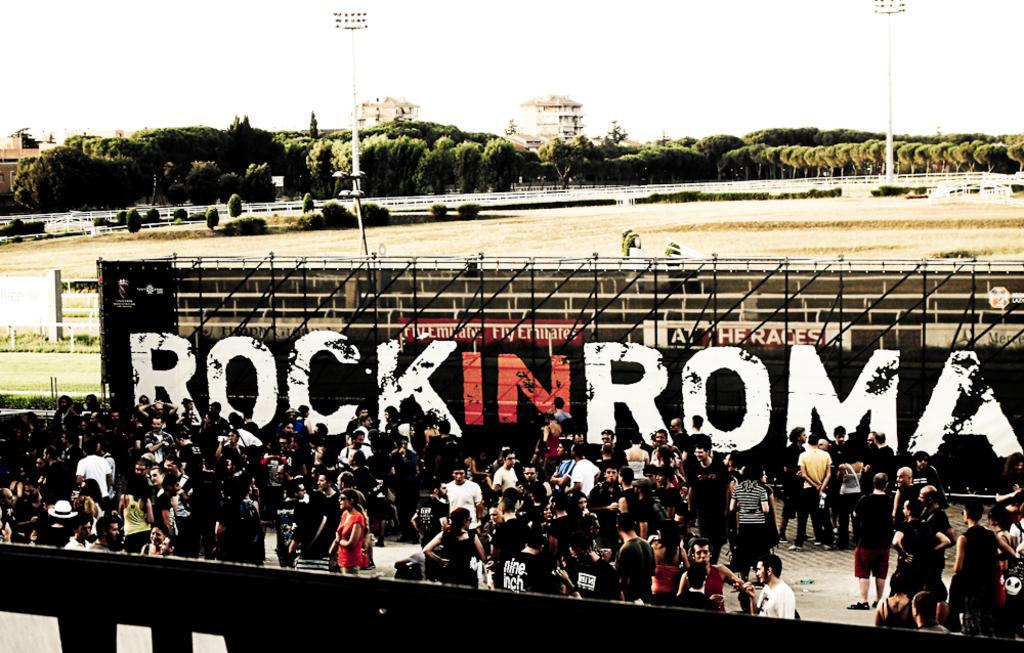How would you summarize this image in a sentence or two? In this image we can see a group of people standing on the ground. In the center of the image we can see sign boards with some text, poles. In the background, we can see a fence, light poles, group of trees, plants, buildings and the sky. 